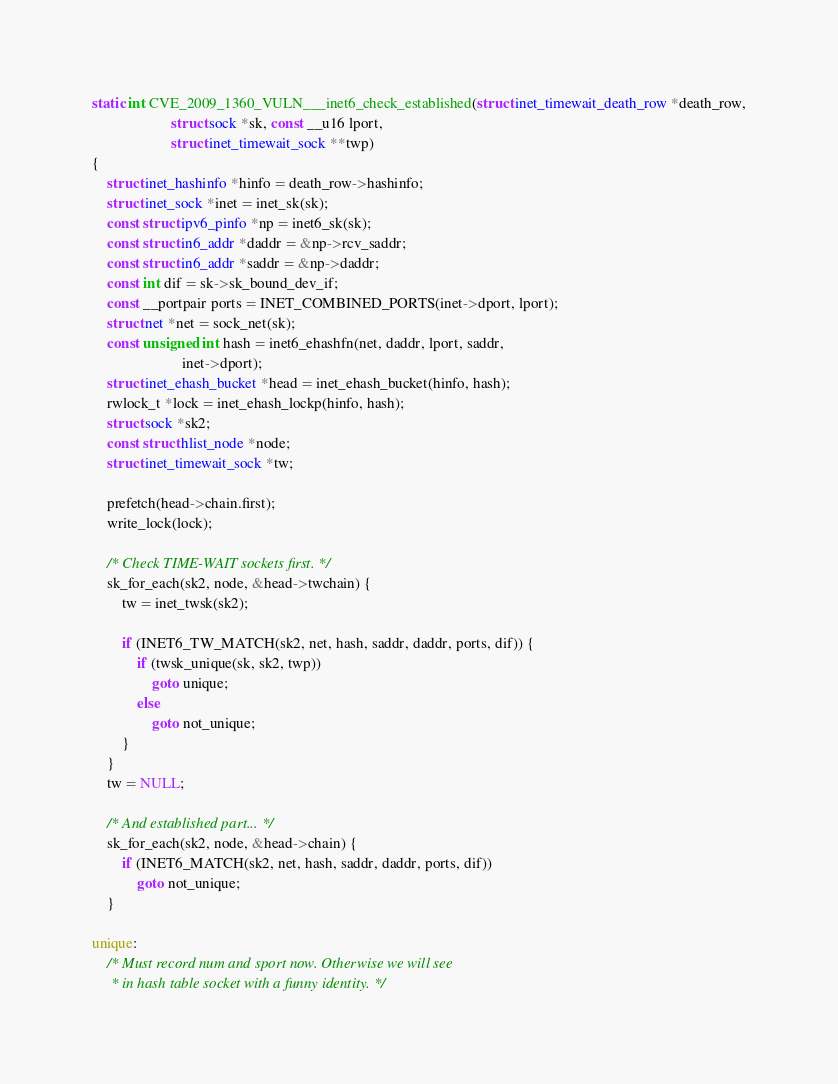<code> <loc_0><loc_0><loc_500><loc_500><_C_>static int CVE_2009_1360_VULN___inet6_check_established(struct inet_timewait_death_row *death_row,
				     struct sock *sk, const __u16 lport,
				     struct inet_timewait_sock **twp)
{
	struct inet_hashinfo *hinfo = death_row->hashinfo;
	struct inet_sock *inet = inet_sk(sk);
	const struct ipv6_pinfo *np = inet6_sk(sk);
	const struct in6_addr *daddr = &np->rcv_saddr;
	const struct in6_addr *saddr = &np->daddr;
	const int dif = sk->sk_bound_dev_if;
	const __portpair ports = INET_COMBINED_PORTS(inet->dport, lport);
	struct net *net = sock_net(sk);
	const unsigned int hash = inet6_ehashfn(net, daddr, lport, saddr,
						inet->dport);
	struct inet_ehash_bucket *head = inet_ehash_bucket(hinfo, hash);
	rwlock_t *lock = inet_ehash_lockp(hinfo, hash);
	struct sock *sk2;
	const struct hlist_node *node;
	struct inet_timewait_sock *tw;

	prefetch(head->chain.first);
	write_lock(lock);

	/* Check TIME-WAIT sockets first. */
	sk_for_each(sk2, node, &head->twchain) {
		tw = inet_twsk(sk2);

		if (INET6_TW_MATCH(sk2, net, hash, saddr, daddr, ports, dif)) {
			if (twsk_unique(sk, sk2, twp))
				goto unique;
			else
				goto not_unique;
		}
	}
	tw = NULL;

	/* And established part... */
	sk_for_each(sk2, node, &head->chain) {
		if (INET6_MATCH(sk2, net, hash, saddr, daddr, ports, dif))
			goto not_unique;
	}

unique:
	/* Must record num and sport now. Otherwise we will see
	 * in hash table socket with a funny identity. */</code> 